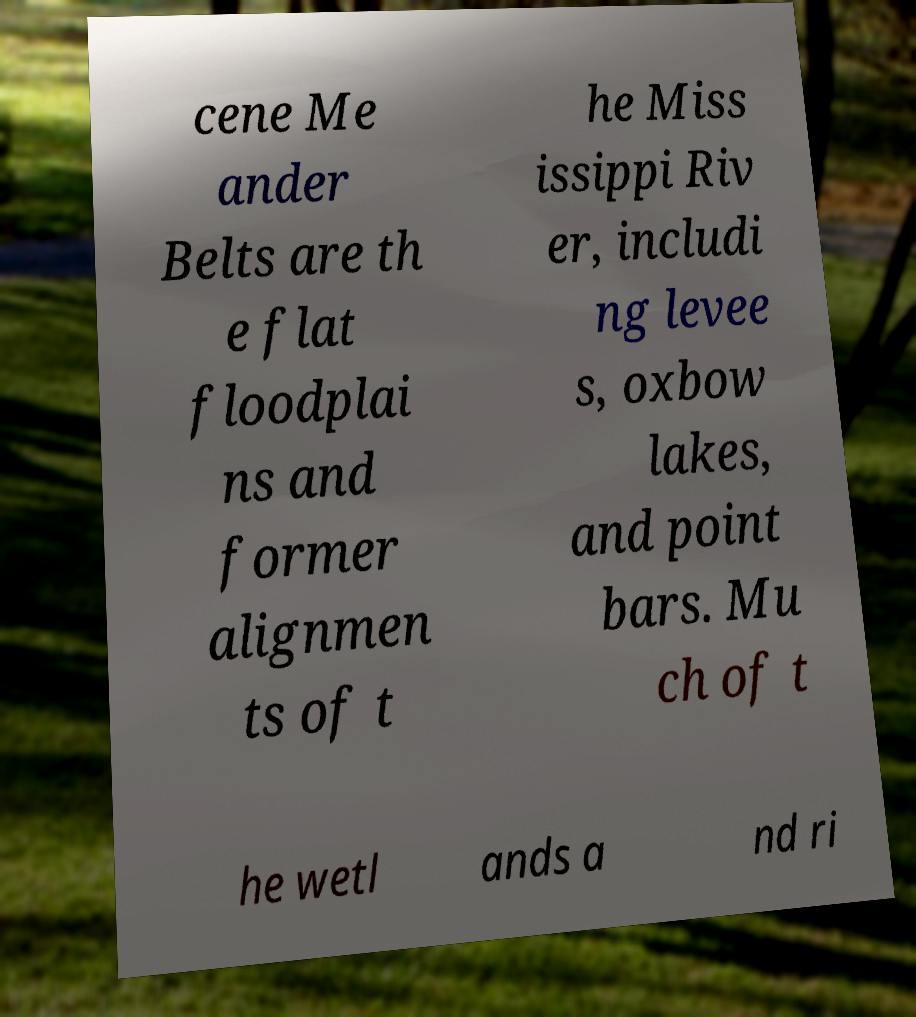I need the written content from this picture converted into text. Can you do that? cene Me ander Belts are th e flat floodplai ns and former alignmen ts of t he Miss issippi Riv er, includi ng levee s, oxbow lakes, and point bars. Mu ch of t he wetl ands a nd ri 